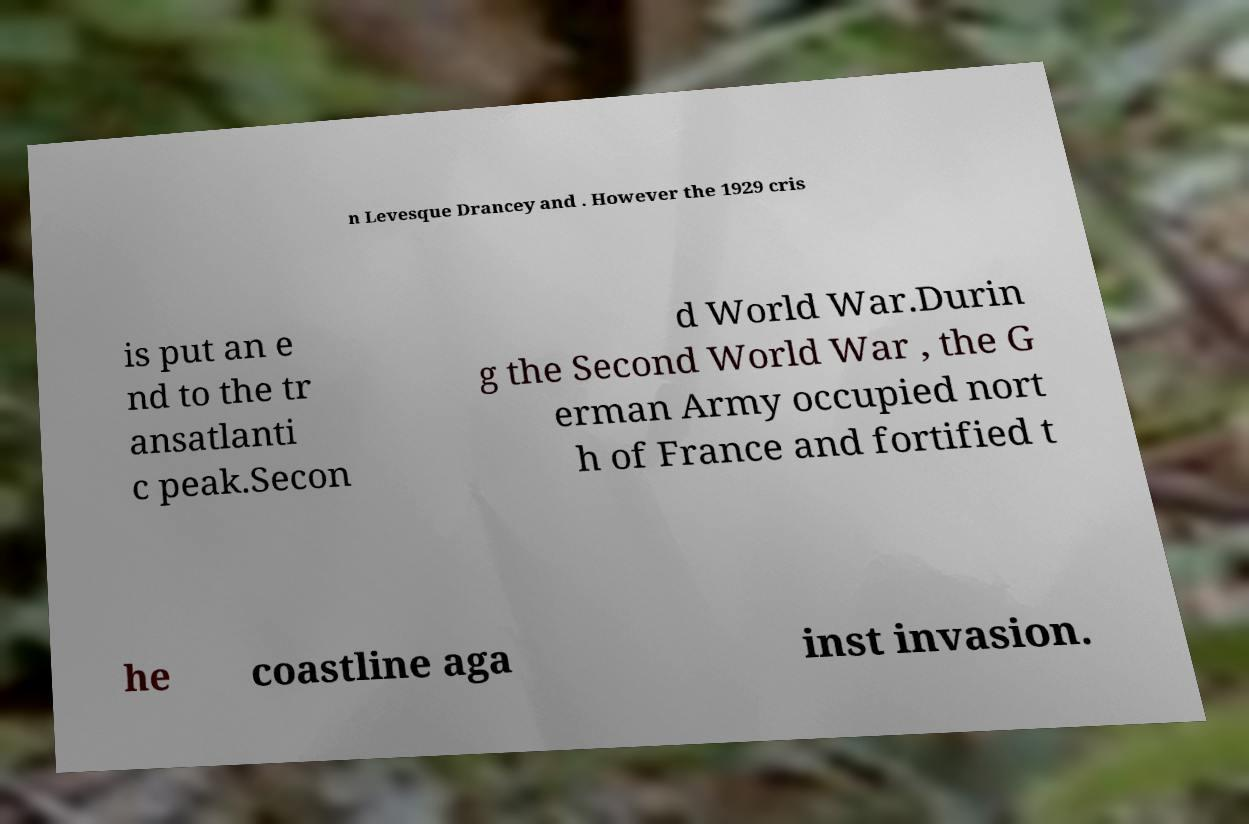For documentation purposes, I need the text within this image transcribed. Could you provide that? n Levesque Drancey and . However the 1929 cris is put an e nd to the tr ansatlanti c peak.Secon d World War.Durin g the Second World War , the G erman Army occupied nort h of France and fortified t he coastline aga inst invasion. 